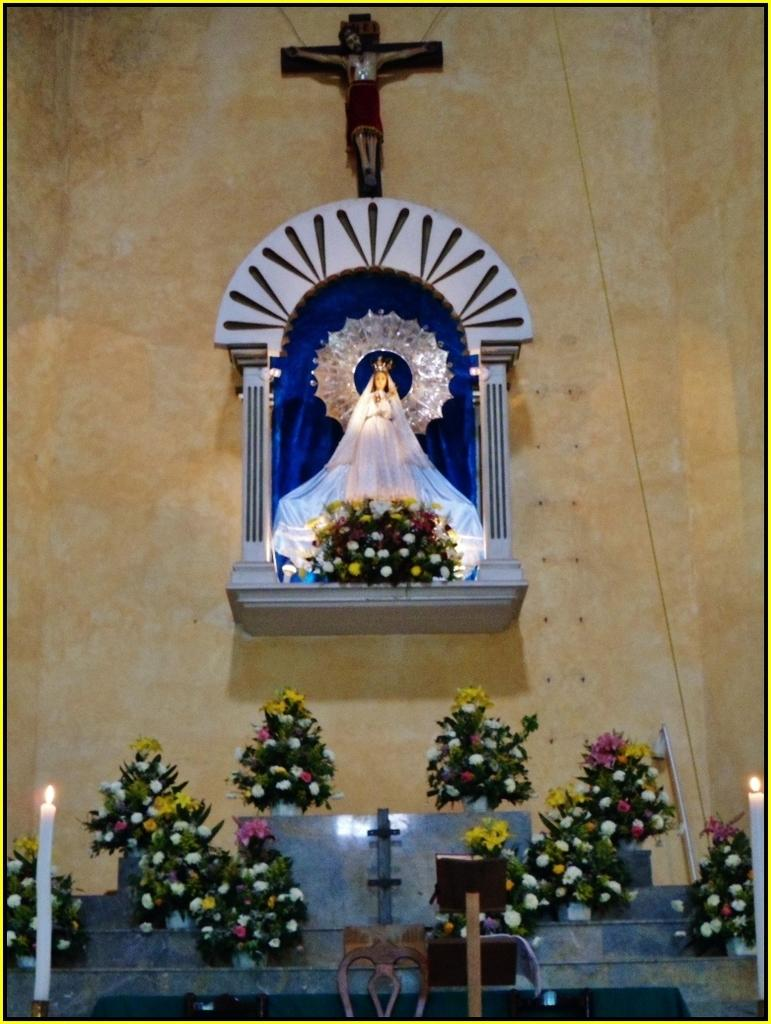What can be seen on the wall in the image? There are sculptures on the wall in the image. What is placed in front of the sculptures? Flower bouquets and candles are visible in front of the sculptures. Are there any other objects in front of the sculptures? Yes, there are other objects in front of the sculptures. Can you see a cap being used to hit the sculptures in the image? There is no cap or any object being used to hit the sculptures in the image. 